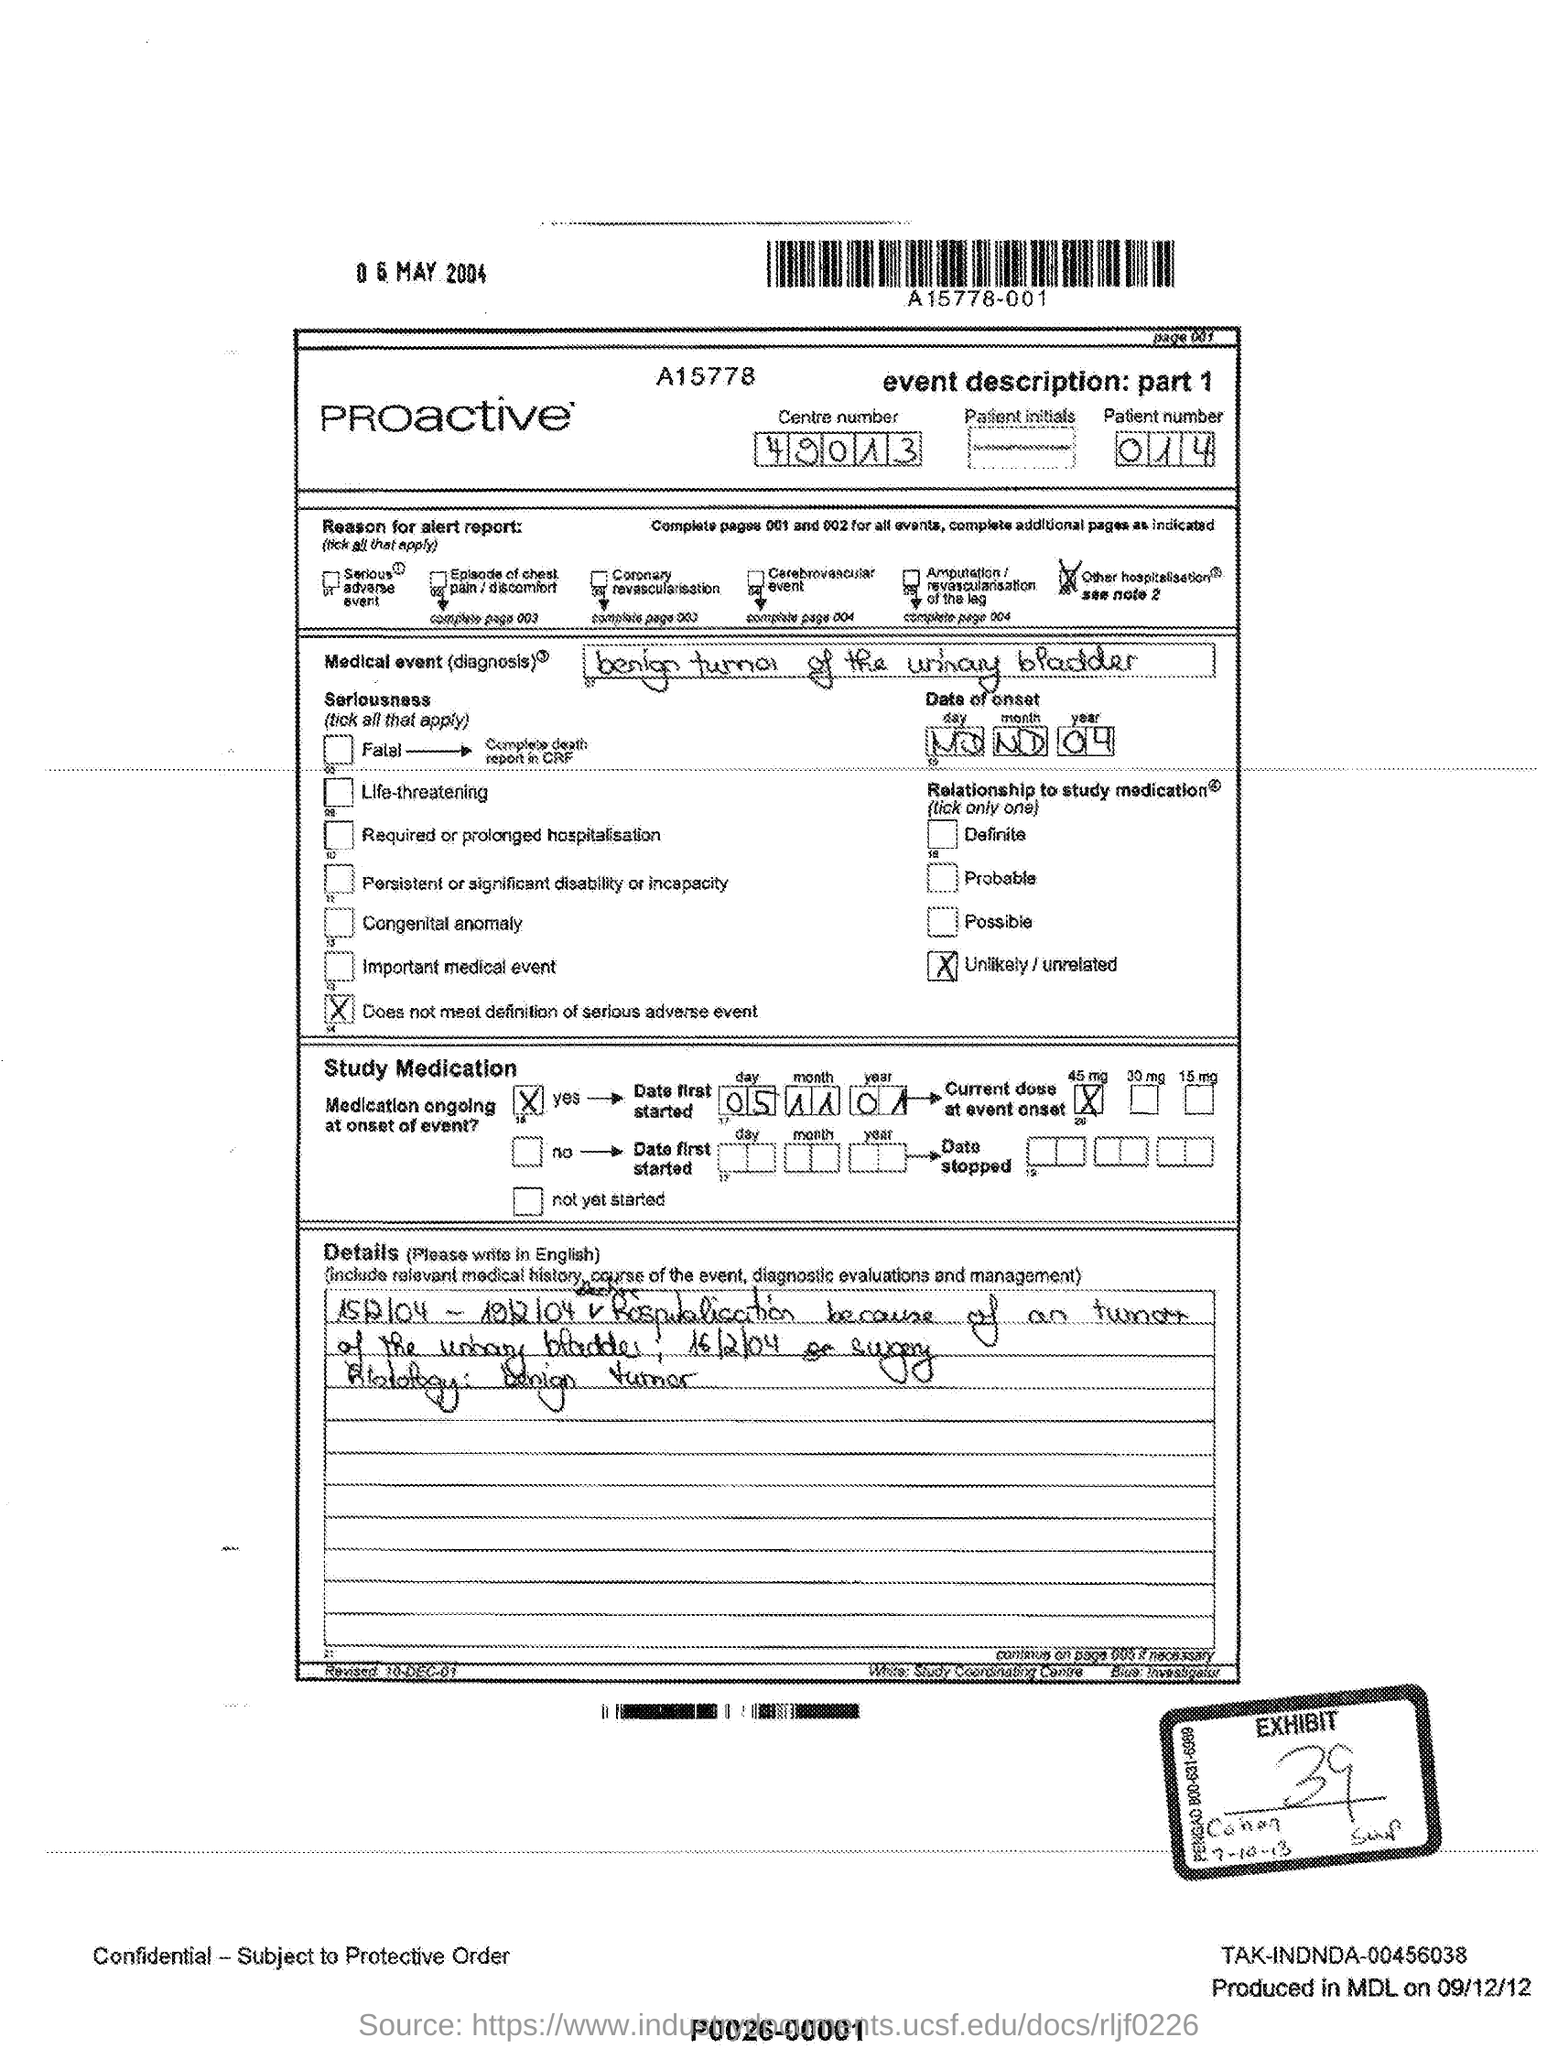What is the patient number?
Provide a short and direct response. 014. What is diagnosis?
Provide a short and direct response. Benign tumor of the urinary bladder. What is the exhibit number?
Your answer should be very brief. 39. 